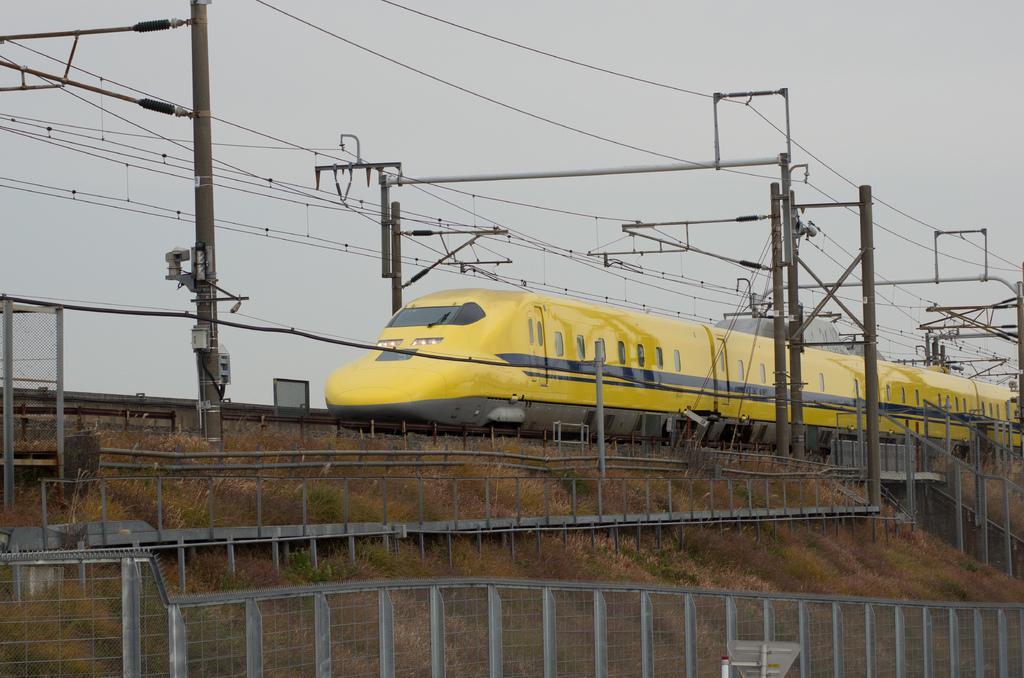Describe this image in one or two sentences. In this image we can see a yellow color train, there are some poles, wires, grass and fence, in the background we can see the sky. 